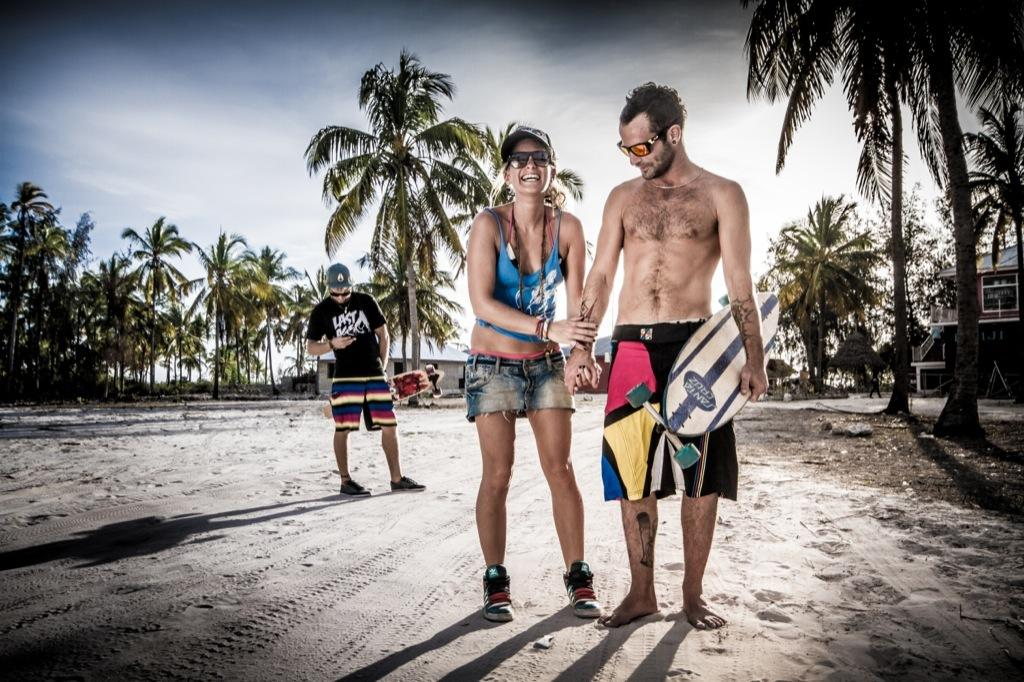How many people are in the image? There is a group of people in the image. What are the people doing in the image? The people are standing on the ground. Can you describe any objects the people are holding? Two men are holding skateboards. What can be seen in the background of the image? There is a group of trees, buildings, a railing, and the sky visible in the background of the image. What type of shoes are the people wearing while twisting and kicking in the image? There is no indication in the image that the people are twisting or kicking, nor is there any mention of shoes. 